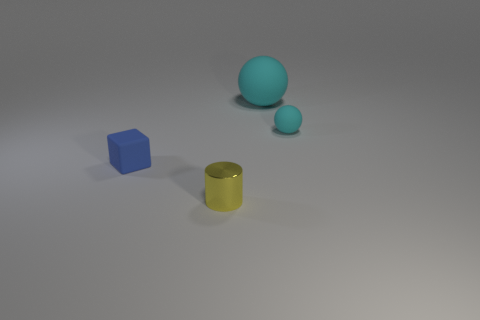There is a small thing that is behind the object that is on the left side of the tiny metal thing; what number of metallic cylinders are in front of it?
Ensure brevity in your answer.  1. What is the object that is both behind the metallic cylinder and in front of the tiny cyan rubber object made of?
Offer a very short reply. Rubber. The big ball has what color?
Your answer should be very brief. Cyan. Are there more blue matte objects that are on the left side of the big cyan thing than objects behind the small cube?
Make the answer very short. No. The matte sphere behind the tiny matte sphere is what color?
Provide a succinct answer. Cyan. There is a thing in front of the tiny rubber block; is it the same size as the rubber object in front of the small cyan object?
Ensure brevity in your answer.  Yes. How many objects are matte blocks or large spheres?
Give a very brief answer. 2. What material is the yellow cylinder in front of the small matte thing to the right of the tiny metal thing made of?
Your answer should be very brief. Metal. What number of other big cyan matte things have the same shape as the big cyan object?
Offer a very short reply. 0. Are there any tiny objects of the same color as the cube?
Make the answer very short. No. 